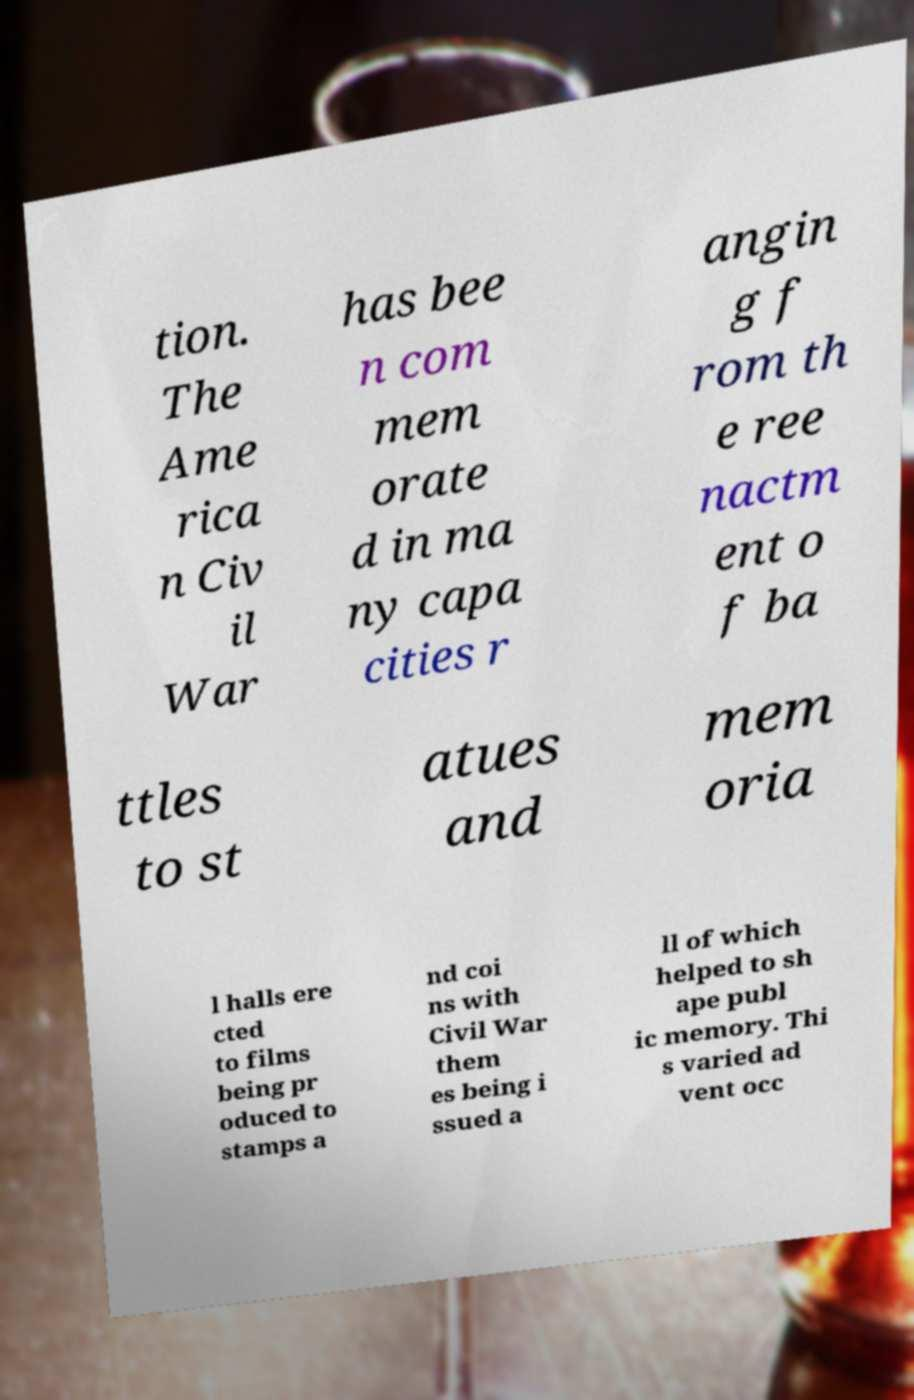There's text embedded in this image that I need extracted. Can you transcribe it verbatim? tion. The Ame rica n Civ il War has bee n com mem orate d in ma ny capa cities r angin g f rom th e ree nactm ent o f ba ttles to st atues and mem oria l halls ere cted to films being pr oduced to stamps a nd coi ns with Civil War them es being i ssued a ll of which helped to sh ape publ ic memory. Thi s varied ad vent occ 